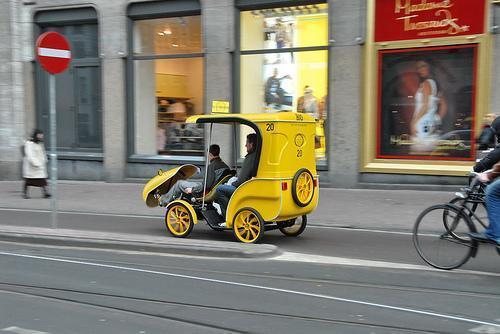How many people are walking on the sidewalk?
Give a very brief answer. 1. How many wheels does the bike in the forefront of the picture have?
Give a very brief answer. 4. How many horses are eating grass?
Give a very brief answer. 0. 